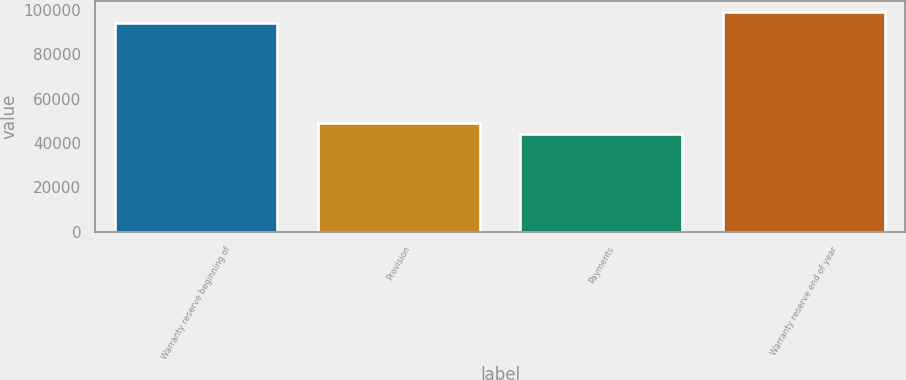<chart> <loc_0><loc_0><loc_500><loc_500><bar_chart><fcel>Warranty reserve beginning of<fcel>Provision<fcel>Payments<fcel>Warranty reserve end of year<nl><fcel>93895<fcel>49081.9<fcel>44034<fcel>98942.9<nl></chart> 